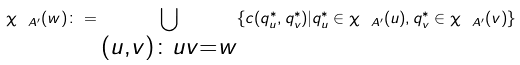<formula> <loc_0><loc_0><loc_500><loc_500>\chi _ { \ A ^ { \prime } } ( w ) \colon = \bigcup _ { \substack { ( u , v ) \colon u v = w } } \{ c ( q ^ { * } _ { u } , q ^ { * } _ { v } ) | q ^ { * } _ { u } \in \chi _ { \ A ^ { \prime } } ( u ) , q ^ { * } _ { v } \in \chi _ { \ A ^ { \prime } } ( v ) \}</formula> 